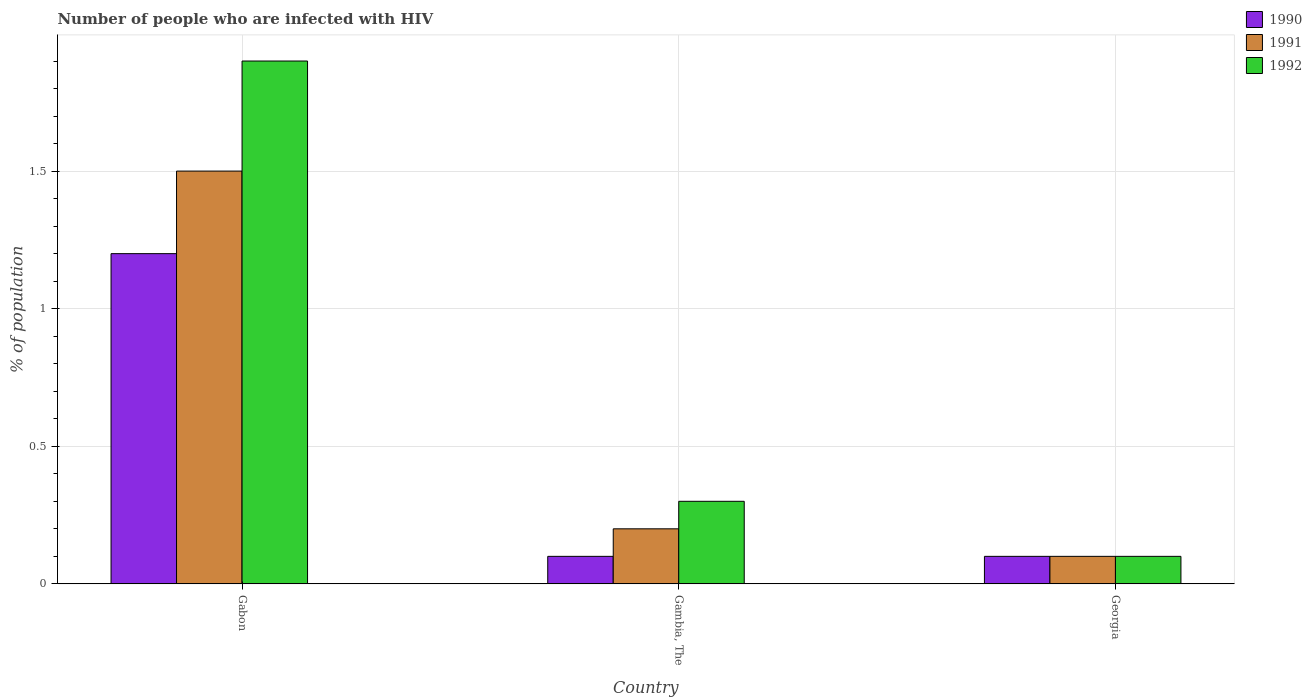How many groups of bars are there?
Provide a short and direct response. 3. Are the number of bars on each tick of the X-axis equal?
Give a very brief answer. Yes. What is the label of the 2nd group of bars from the left?
Give a very brief answer. Gambia, The. In how many cases, is the number of bars for a given country not equal to the number of legend labels?
Offer a very short reply. 0. What is the percentage of HIV infected population in in 1990 in Gambia, The?
Give a very brief answer. 0.1. Across all countries, what is the maximum percentage of HIV infected population in in 1991?
Make the answer very short. 1.5. Across all countries, what is the minimum percentage of HIV infected population in in 1990?
Offer a very short reply. 0.1. In which country was the percentage of HIV infected population in in 1991 maximum?
Keep it short and to the point. Gabon. In which country was the percentage of HIV infected population in in 1990 minimum?
Offer a terse response. Gambia, The. What is the total percentage of HIV infected population in in 1990 in the graph?
Give a very brief answer. 1.4. What is the difference between the percentage of HIV infected population in in 1992 in Gambia, The and that in Georgia?
Your response must be concise. 0.2. What is the average percentage of HIV infected population in in 1991 per country?
Ensure brevity in your answer.  0.6. What is the difference between the highest and the second highest percentage of HIV infected population in in 1990?
Provide a succinct answer. -1.1. What is the difference between the highest and the lowest percentage of HIV infected population in in 1990?
Provide a short and direct response. 1.1. Is the sum of the percentage of HIV infected population in in 1991 in Gabon and Gambia, The greater than the maximum percentage of HIV infected population in in 1990 across all countries?
Offer a terse response. Yes. What does the 3rd bar from the left in Georgia represents?
Make the answer very short. 1992. What does the 2nd bar from the right in Gabon represents?
Give a very brief answer. 1991. Is it the case that in every country, the sum of the percentage of HIV infected population in in 1992 and percentage of HIV infected population in in 1991 is greater than the percentage of HIV infected population in in 1990?
Offer a terse response. Yes. How many bars are there?
Provide a short and direct response. 9. Are all the bars in the graph horizontal?
Give a very brief answer. No. How many countries are there in the graph?
Provide a succinct answer. 3. Are the values on the major ticks of Y-axis written in scientific E-notation?
Keep it short and to the point. No. Does the graph contain any zero values?
Offer a terse response. No. How many legend labels are there?
Your answer should be very brief. 3. How are the legend labels stacked?
Offer a terse response. Vertical. What is the title of the graph?
Your response must be concise. Number of people who are infected with HIV. What is the label or title of the Y-axis?
Provide a short and direct response. % of population. What is the % of population of 1991 in Gabon?
Give a very brief answer. 1.5. What is the % of population of 1992 in Gabon?
Offer a very short reply. 1.9. What is the % of population in 1990 in Gambia, The?
Your response must be concise. 0.1. What is the % of population in 1991 in Gambia, The?
Make the answer very short. 0.2. What is the % of population in 1992 in Gambia, The?
Ensure brevity in your answer.  0.3. What is the % of population of 1990 in Georgia?
Offer a terse response. 0.1. What is the % of population in 1992 in Georgia?
Your answer should be compact. 0.1. Across all countries, what is the maximum % of population in 1991?
Give a very brief answer. 1.5. Across all countries, what is the maximum % of population in 1992?
Your answer should be compact. 1.9. Across all countries, what is the minimum % of population in 1990?
Make the answer very short. 0.1. Across all countries, what is the minimum % of population in 1991?
Ensure brevity in your answer.  0.1. Across all countries, what is the minimum % of population in 1992?
Give a very brief answer. 0.1. What is the total % of population of 1992 in the graph?
Give a very brief answer. 2.3. What is the difference between the % of population in 1992 in Gambia, The and that in Georgia?
Ensure brevity in your answer.  0.2. What is the difference between the % of population of 1990 in Gabon and the % of population of 1991 in Gambia, The?
Your answer should be very brief. 1. What is the difference between the % of population of 1990 in Gabon and the % of population of 1992 in Gambia, The?
Offer a terse response. 0.9. What is the difference between the % of population in 1990 in Gabon and the % of population in 1991 in Georgia?
Offer a terse response. 1.1. What is the difference between the % of population of 1991 in Gabon and the % of population of 1992 in Georgia?
Provide a short and direct response. 1.4. What is the difference between the % of population of 1991 in Gambia, The and the % of population of 1992 in Georgia?
Provide a succinct answer. 0.1. What is the average % of population in 1990 per country?
Keep it short and to the point. 0.47. What is the average % of population in 1991 per country?
Offer a very short reply. 0.6. What is the average % of population of 1992 per country?
Your answer should be very brief. 0.77. What is the difference between the % of population of 1990 and % of population of 1991 in Gabon?
Provide a short and direct response. -0.3. What is the difference between the % of population in 1990 and % of population in 1992 in Gabon?
Offer a very short reply. -0.7. What is the difference between the % of population in 1991 and % of population in 1992 in Gabon?
Offer a terse response. -0.4. What is the difference between the % of population in 1990 and % of population in 1991 in Gambia, The?
Provide a short and direct response. -0.1. What is the difference between the % of population in 1991 and % of population in 1992 in Gambia, The?
Make the answer very short. -0.1. What is the difference between the % of population of 1990 and % of population of 1992 in Georgia?
Provide a succinct answer. 0. What is the ratio of the % of population in 1990 in Gabon to that in Gambia, The?
Ensure brevity in your answer.  12. What is the ratio of the % of population of 1991 in Gabon to that in Gambia, The?
Ensure brevity in your answer.  7.5. What is the ratio of the % of population in 1992 in Gabon to that in Gambia, The?
Keep it short and to the point. 6.33. What is the ratio of the % of population in 1990 in Gabon to that in Georgia?
Ensure brevity in your answer.  12. What is the ratio of the % of population of 1991 in Gabon to that in Georgia?
Your answer should be very brief. 15. What is the ratio of the % of population of 1992 in Gabon to that in Georgia?
Your answer should be compact. 19. What is the ratio of the % of population of 1990 in Gambia, The to that in Georgia?
Keep it short and to the point. 1. What is the ratio of the % of population of 1992 in Gambia, The to that in Georgia?
Your answer should be very brief. 3. What is the difference between the highest and the second highest % of population in 1990?
Give a very brief answer. 1.1. What is the difference between the highest and the second highest % of population in 1991?
Make the answer very short. 1.3. What is the difference between the highest and the lowest % of population in 1991?
Provide a succinct answer. 1.4. What is the difference between the highest and the lowest % of population of 1992?
Your answer should be compact. 1.8. 